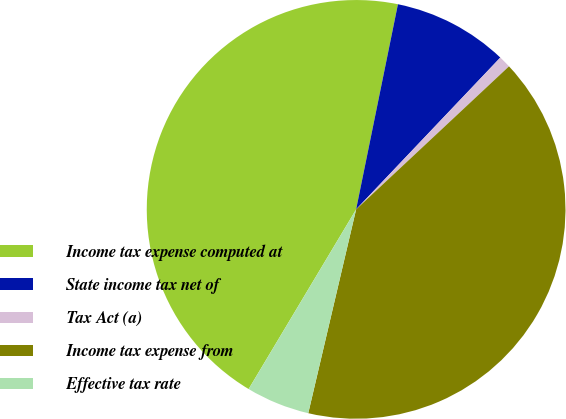Convert chart. <chart><loc_0><loc_0><loc_500><loc_500><pie_chart><fcel>Income tax expense computed at<fcel>State income tax net of<fcel>Tax Act (a)<fcel>Income tax expense from<fcel>Effective tax rate<nl><fcel>44.62%<fcel>8.89%<fcel>0.94%<fcel>40.64%<fcel>4.91%<nl></chart> 